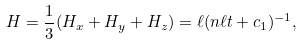<formula> <loc_0><loc_0><loc_500><loc_500>H = \frac { 1 } { 3 } ( H _ { x } + H _ { y } + H _ { z } ) = \ell ( n \ell t + c _ { 1 } ) ^ { - 1 } ,</formula> 